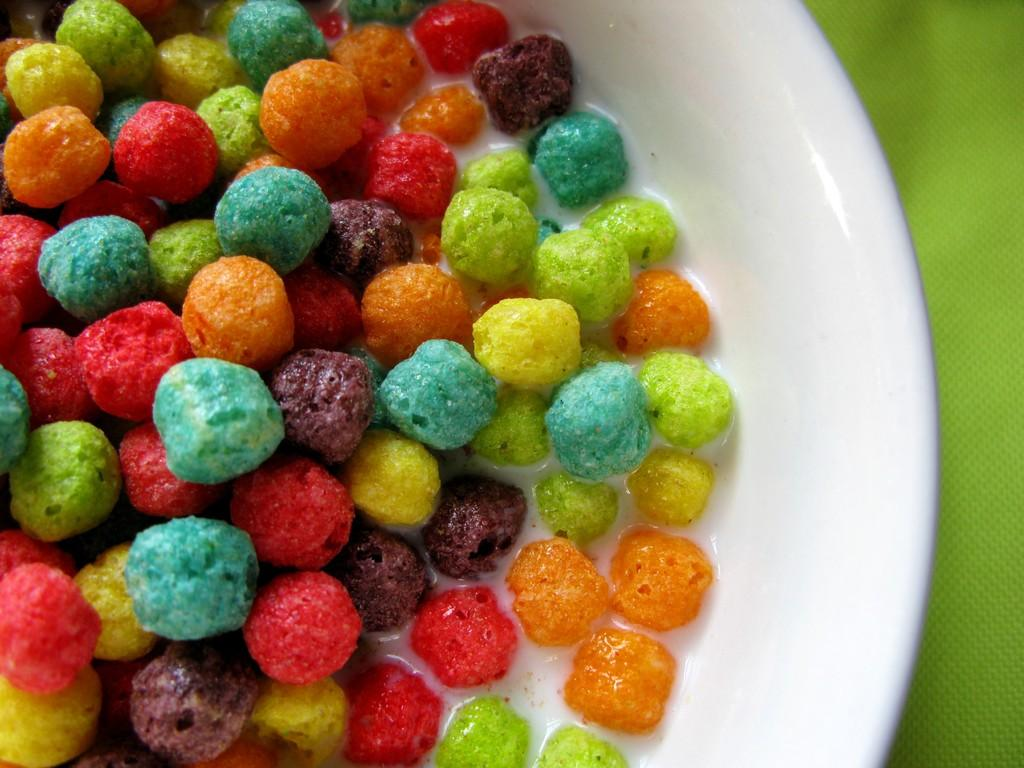What is present in the image? There is a bowl in the image. What is inside the bowl? The bowl contains food items. What type of cushion can be seen supporting the food items in the bowl? There is no cushion present in the image; the bowl is simply resting on a surface. 